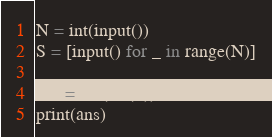Convert code to text. <code><loc_0><loc_0><loc_500><loc_500><_Python_>N = int(input())
S = [input() for _ in range(N)]

ans = len(set(S))
print(ans)</code> 